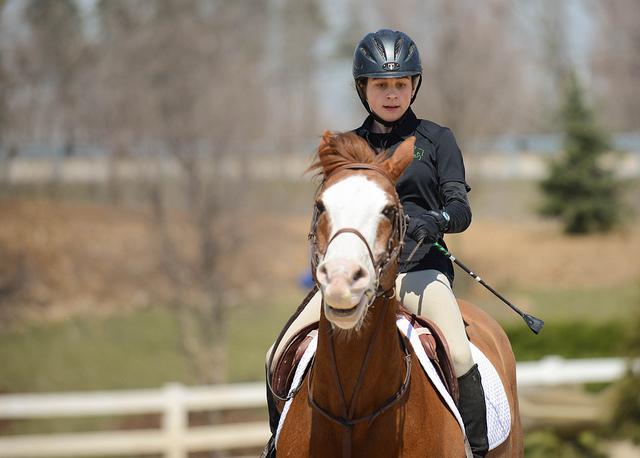What is the color of the horse?
Short answer required. Brown and white. Does the horse look happy?
Quick response, please. Yes. Is the jockey a woman or a girl?
Answer briefly. Girl. 